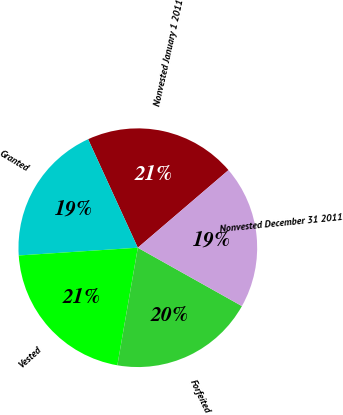Convert chart. <chart><loc_0><loc_0><loc_500><loc_500><pie_chart><fcel>Nonvested January 1 2011<fcel>Granted<fcel>Vested<fcel>Forfeited<fcel>Nonvested December 31 2011<nl><fcel>20.57%<fcel>19.2%<fcel>21.22%<fcel>19.61%<fcel>19.4%<nl></chart> 